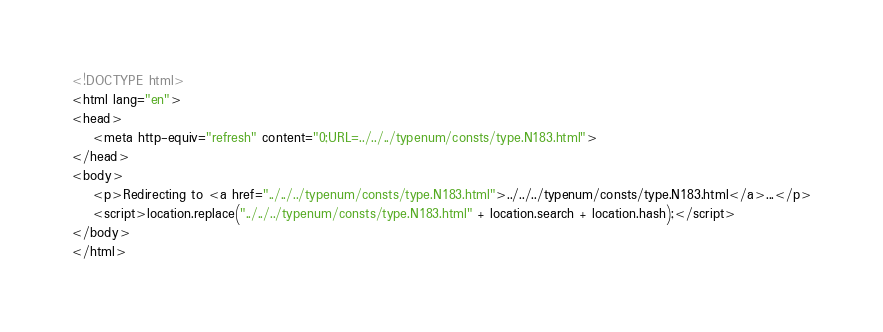<code> <loc_0><loc_0><loc_500><loc_500><_HTML_><!DOCTYPE html>
<html lang="en">
<head>
    <meta http-equiv="refresh" content="0;URL=../../../typenum/consts/type.N183.html">
</head>
<body>
    <p>Redirecting to <a href="../../../typenum/consts/type.N183.html">../../../typenum/consts/type.N183.html</a>...</p>
    <script>location.replace("../../../typenum/consts/type.N183.html" + location.search + location.hash);</script>
</body>
</html></code> 